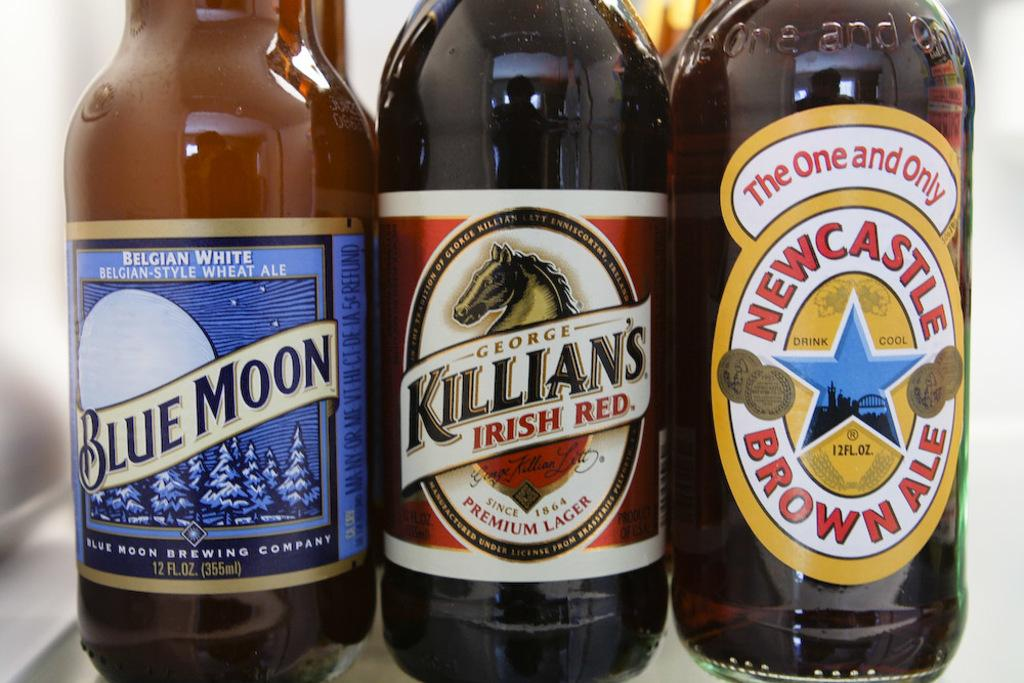<image>
Create a compact narrative representing the image presented. Three bottles on a shelf, Blue Moon Wheat Ale, Killians Irish Red and New Castle Brown ale. 